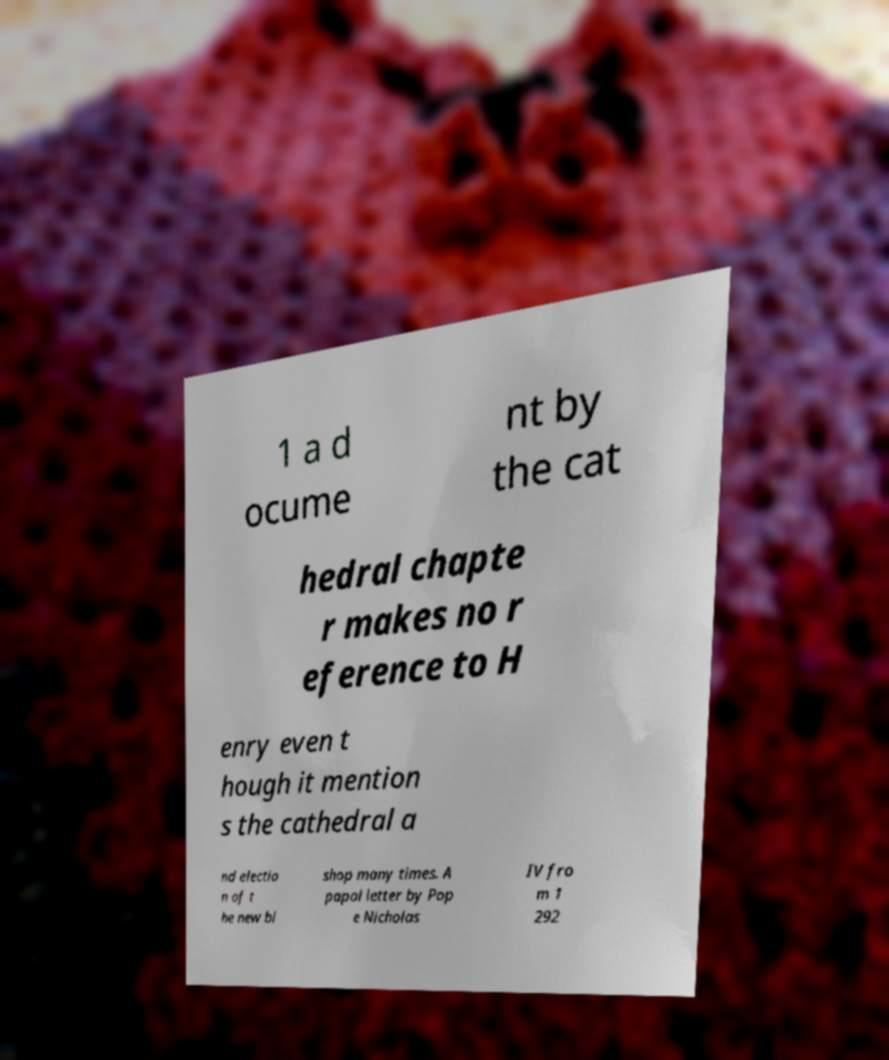Please read and relay the text visible in this image. What does it say? 1 a d ocume nt by the cat hedral chapte r makes no r eference to H enry even t hough it mention s the cathedral a nd electio n of t he new bi shop many times. A papal letter by Pop e Nicholas IV fro m 1 292 